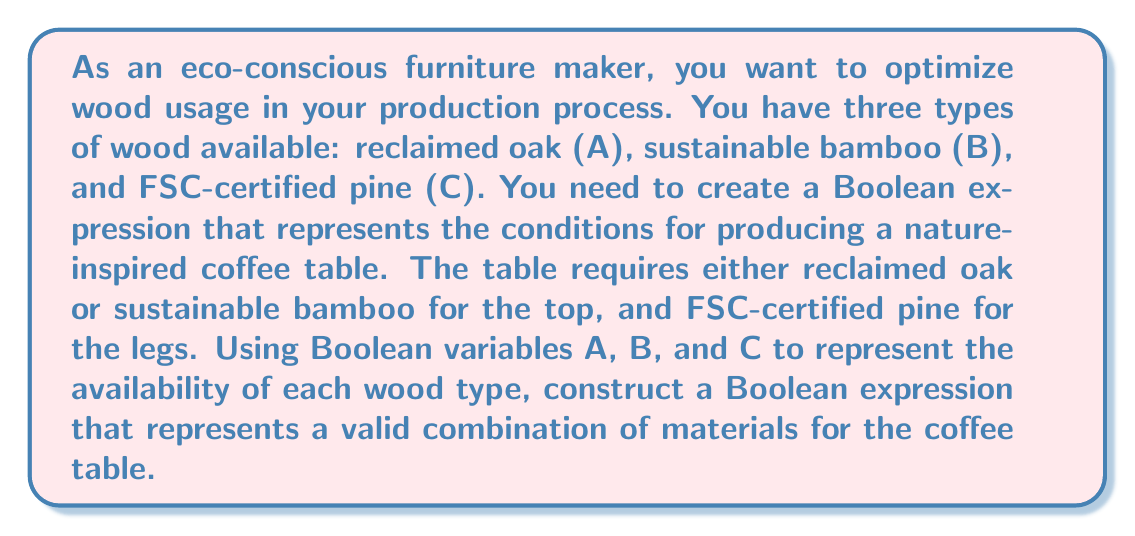Can you answer this question? Let's approach this step-by-step:

1) First, we need to consider the requirements for the coffee table:
   - The top requires either reclaimed oak (A) OR sustainable bamboo (B)
   - The legs require FSC-certified pine (C)

2) We can represent the top requirement as:
   $A + B$ (where '+' represents the OR operation in Boolean algebra)

3) The legs requirement is simply represented by C

4) For a valid combination, we need BOTH the top AND the legs requirements to be met. In Boolean algebra, AND is represented by multiplication or concatenation.

5) Therefore, we can combine these requirements as:
   $(A + B) \cdot C$

6) This expression can be expanded using the distributive property:
   $AC + BC$

7) This final expression, $AC + BC$, represents all valid combinations of materials for the coffee table:
   - AC: Reclaimed oak top with FSC-certified pine legs
   - BC: Sustainable bamboo top with FSC-certified pine legs

Thus, the Boolean expression $AC + BC$ optimizes wood usage by ensuring that only the required materials are used for each possible combination.
Answer: $AC + BC$ 